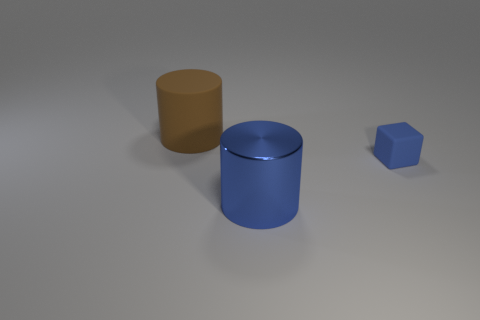Do the metallic cylinder and the matte cube have the same color?
Keep it short and to the point. Yes. The other object that is the same shape as the brown rubber object is what size?
Provide a succinct answer. Large. There is a big object right of the brown rubber object; is it the same shape as the large thing that is behind the big shiny object?
Your answer should be very brief. Yes. There is a metal cylinder that is the same color as the tiny thing; what is its size?
Keep it short and to the point. Large. What color is the thing that is the same size as the brown matte cylinder?
Give a very brief answer. Blue. Does the cube have the same size as the cylinder in front of the brown matte thing?
Keep it short and to the point. No. What number of tiny rubber cubes are the same color as the shiny thing?
Give a very brief answer. 1. What number of objects are either big purple blocks or big objects that are left of the big shiny cylinder?
Keep it short and to the point. 1. Does the matte thing that is on the right side of the large metallic object have the same size as the rubber object behind the small blue cube?
Offer a terse response. No. Is there a tiny blue object made of the same material as the brown cylinder?
Provide a short and direct response. Yes. 